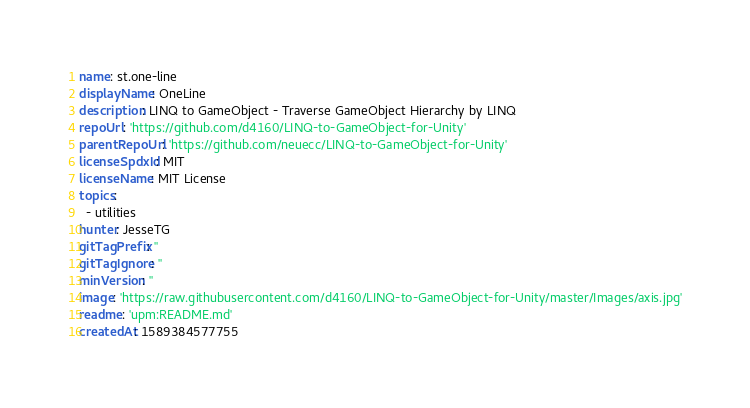<code> <loc_0><loc_0><loc_500><loc_500><_YAML_>name: st.one-line
displayName: OneLine
description: LINQ to GameObject - Traverse GameObject Hierarchy by LINQ
repoUrl: 'https://github.com/d4160/LINQ-to-GameObject-for-Unity'
parentRepoUrl: 'https://github.com/neuecc/LINQ-to-GameObject-for-Unity'
licenseSpdxId: MIT
licenseName: MIT License
topics:
  - utilities
hunter: JesseTG
gitTagPrefix: ''
gitTagIgnore: ''
minVersion: ''
image: 'https://raw.githubusercontent.com/d4160/LINQ-to-GameObject-for-Unity/master/Images/axis.jpg'
readme: 'upm:README.md'
createdAt: 1589384577755
</code> 